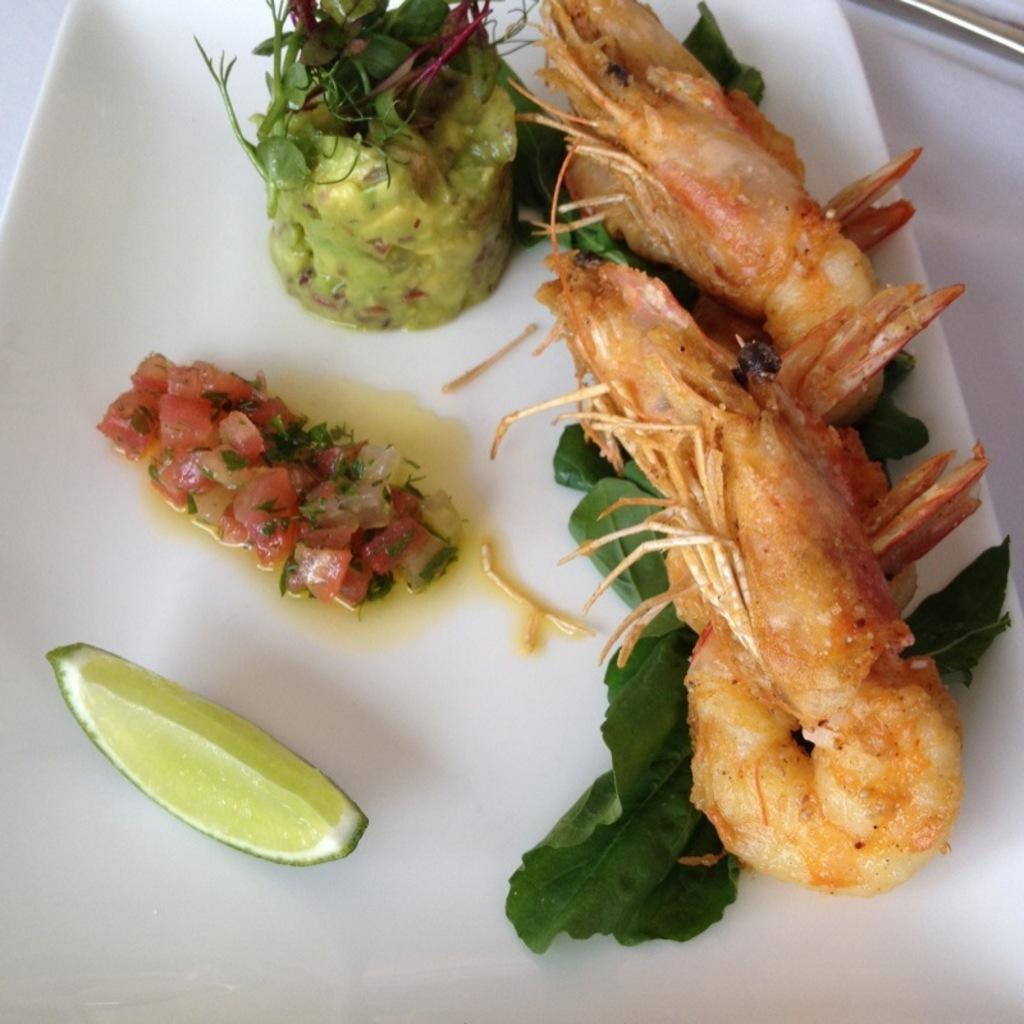What is on the serving plate in the image? The serving plate contains salad, fried prawns, leaves, and a lemon wedge. What type of food is included in the salad? The specific ingredients of the salad are not mentioned in the facts, so we cannot determine the type of food in the salad. What is the purpose of the lemon wedge on the serving plate? The lemon wedge may be used for adding flavor or garnishing the dish. Are there any other items on the serving plate besides the food? No, the facts only mention the food items and the lemon wedge on the serving plate. How many railway tracks can be seen in the image? There are no railway tracks present in the image; it features a serving plate with food items. What type of finger is used to pick up the fried prawns in the image? There is no finger present in the image; it only shows the food items on the serving plate. 